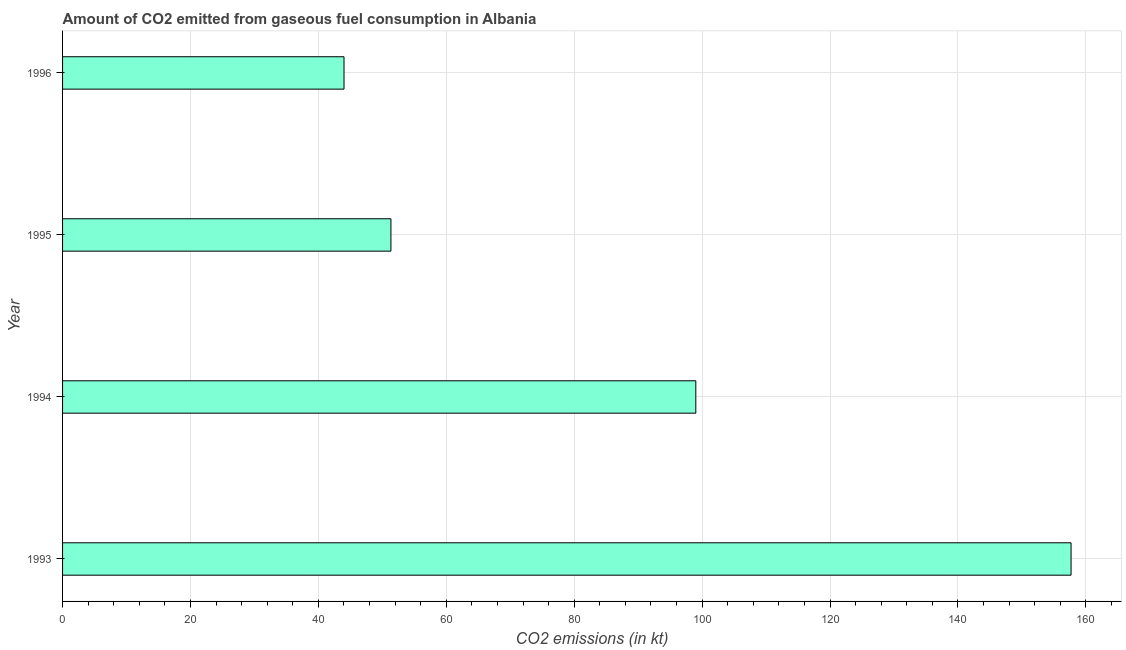Does the graph contain any zero values?
Provide a succinct answer. No. What is the title of the graph?
Give a very brief answer. Amount of CO2 emitted from gaseous fuel consumption in Albania. What is the label or title of the X-axis?
Keep it short and to the point. CO2 emissions (in kt). What is the label or title of the Y-axis?
Make the answer very short. Year. What is the co2 emissions from gaseous fuel consumption in 1994?
Offer a terse response. 99.01. Across all years, what is the maximum co2 emissions from gaseous fuel consumption?
Provide a short and direct response. 157.68. Across all years, what is the minimum co2 emissions from gaseous fuel consumption?
Your answer should be very brief. 44. In which year was the co2 emissions from gaseous fuel consumption minimum?
Provide a succinct answer. 1996. What is the sum of the co2 emissions from gaseous fuel consumption?
Your answer should be very brief. 352.03. What is the difference between the co2 emissions from gaseous fuel consumption in 1993 and 1994?
Your answer should be very brief. 58.67. What is the average co2 emissions from gaseous fuel consumption per year?
Provide a succinct answer. 88.01. What is the median co2 emissions from gaseous fuel consumption?
Your answer should be compact. 75.17. What is the ratio of the co2 emissions from gaseous fuel consumption in 1994 to that in 1995?
Make the answer very short. 1.93. Is the co2 emissions from gaseous fuel consumption in 1994 less than that in 1996?
Provide a succinct answer. No. Is the difference between the co2 emissions from gaseous fuel consumption in 1994 and 1996 greater than the difference between any two years?
Ensure brevity in your answer.  No. What is the difference between the highest and the second highest co2 emissions from gaseous fuel consumption?
Ensure brevity in your answer.  58.67. What is the difference between the highest and the lowest co2 emissions from gaseous fuel consumption?
Provide a succinct answer. 113.68. How many bars are there?
Your response must be concise. 4. Are all the bars in the graph horizontal?
Your answer should be compact. Yes. How many years are there in the graph?
Give a very brief answer. 4. What is the difference between two consecutive major ticks on the X-axis?
Make the answer very short. 20. Are the values on the major ticks of X-axis written in scientific E-notation?
Give a very brief answer. No. What is the CO2 emissions (in kt) in 1993?
Provide a short and direct response. 157.68. What is the CO2 emissions (in kt) of 1994?
Ensure brevity in your answer.  99.01. What is the CO2 emissions (in kt) in 1995?
Your answer should be compact. 51.34. What is the CO2 emissions (in kt) in 1996?
Your answer should be compact. 44. What is the difference between the CO2 emissions (in kt) in 1993 and 1994?
Offer a terse response. 58.67. What is the difference between the CO2 emissions (in kt) in 1993 and 1995?
Provide a succinct answer. 106.34. What is the difference between the CO2 emissions (in kt) in 1993 and 1996?
Your response must be concise. 113.68. What is the difference between the CO2 emissions (in kt) in 1994 and 1995?
Provide a succinct answer. 47.67. What is the difference between the CO2 emissions (in kt) in 1994 and 1996?
Give a very brief answer. 55.01. What is the difference between the CO2 emissions (in kt) in 1995 and 1996?
Your response must be concise. 7.33. What is the ratio of the CO2 emissions (in kt) in 1993 to that in 1994?
Keep it short and to the point. 1.59. What is the ratio of the CO2 emissions (in kt) in 1993 to that in 1995?
Offer a terse response. 3.07. What is the ratio of the CO2 emissions (in kt) in 1993 to that in 1996?
Offer a very short reply. 3.58. What is the ratio of the CO2 emissions (in kt) in 1994 to that in 1995?
Offer a very short reply. 1.93. What is the ratio of the CO2 emissions (in kt) in 1994 to that in 1996?
Make the answer very short. 2.25. What is the ratio of the CO2 emissions (in kt) in 1995 to that in 1996?
Your response must be concise. 1.17. 